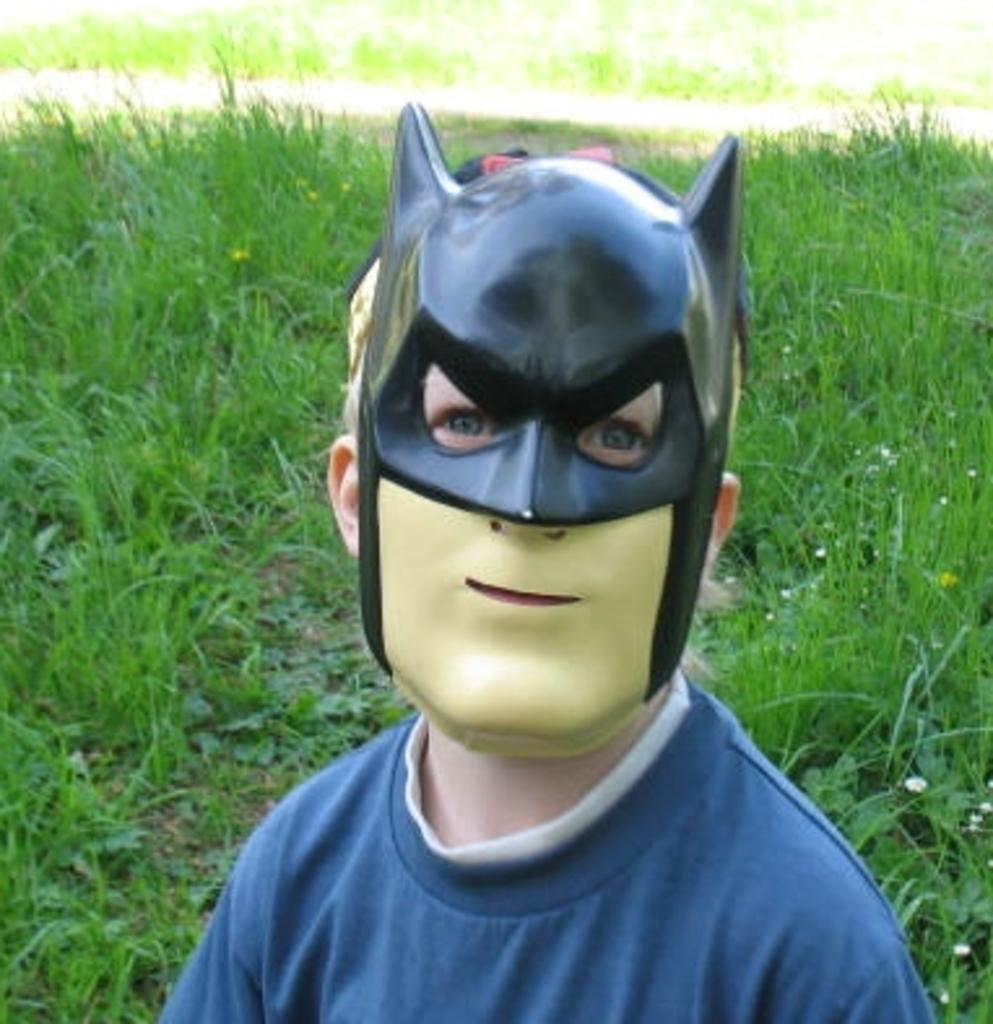Who or what is present in the image? There is a person in the image. What is the person wearing on their face? The person is wearing a mask. What can be seen on the ground in the image? There are plants on the ground in the image. How many bombs can be seen in the image? There are no bombs present in the image. What type of mice are visible in the image? There are no mice present in the image. 